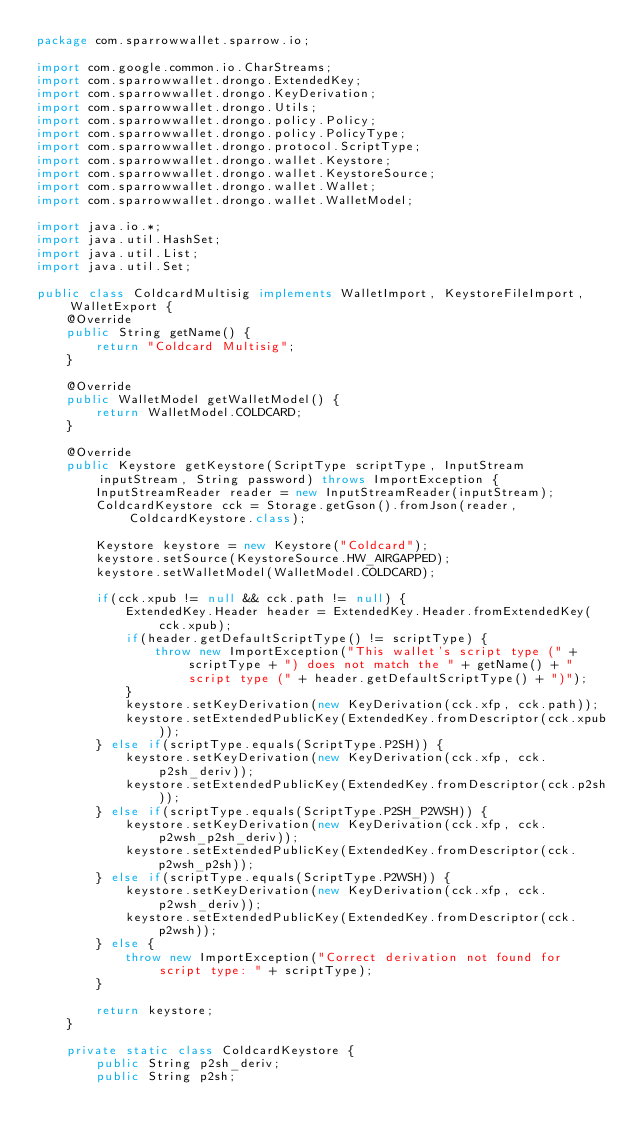<code> <loc_0><loc_0><loc_500><loc_500><_Java_>package com.sparrowwallet.sparrow.io;

import com.google.common.io.CharStreams;
import com.sparrowwallet.drongo.ExtendedKey;
import com.sparrowwallet.drongo.KeyDerivation;
import com.sparrowwallet.drongo.Utils;
import com.sparrowwallet.drongo.policy.Policy;
import com.sparrowwallet.drongo.policy.PolicyType;
import com.sparrowwallet.drongo.protocol.ScriptType;
import com.sparrowwallet.drongo.wallet.Keystore;
import com.sparrowwallet.drongo.wallet.KeystoreSource;
import com.sparrowwallet.drongo.wallet.Wallet;
import com.sparrowwallet.drongo.wallet.WalletModel;

import java.io.*;
import java.util.HashSet;
import java.util.List;
import java.util.Set;

public class ColdcardMultisig implements WalletImport, KeystoreFileImport, WalletExport {
    @Override
    public String getName() {
        return "Coldcard Multisig";
    }

    @Override
    public WalletModel getWalletModel() {
        return WalletModel.COLDCARD;
    }

    @Override
    public Keystore getKeystore(ScriptType scriptType, InputStream inputStream, String password) throws ImportException {
        InputStreamReader reader = new InputStreamReader(inputStream);
        ColdcardKeystore cck = Storage.getGson().fromJson(reader, ColdcardKeystore.class);

        Keystore keystore = new Keystore("Coldcard");
        keystore.setSource(KeystoreSource.HW_AIRGAPPED);
        keystore.setWalletModel(WalletModel.COLDCARD);

        if(cck.xpub != null && cck.path != null) {
            ExtendedKey.Header header = ExtendedKey.Header.fromExtendedKey(cck.xpub);
            if(header.getDefaultScriptType() != scriptType) {
                throw new ImportException("This wallet's script type (" + scriptType + ") does not match the " + getName() + " script type (" + header.getDefaultScriptType() + ")");
            }
            keystore.setKeyDerivation(new KeyDerivation(cck.xfp, cck.path));
            keystore.setExtendedPublicKey(ExtendedKey.fromDescriptor(cck.xpub));
        } else if(scriptType.equals(ScriptType.P2SH)) {
            keystore.setKeyDerivation(new KeyDerivation(cck.xfp, cck.p2sh_deriv));
            keystore.setExtendedPublicKey(ExtendedKey.fromDescriptor(cck.p2sh));
        } else if(scriptType.equals(ScriptType.P2SH_P2WSH)) {
            keystore.setKeyDerivation(new KeyDerivation(cck.xfp, cck.p2wsh_p2sh_deriv));
            keystore.setExtendedPublicKey(ExtendedKey.fromDescriptor(cck.p2wsh_p2sh));
        } else if(scriptType.equals(ScriptType.P2WSH)) {
            keystore.setKeyDerivation(new KeyDerivation(cck.xfp, cck.p2wsh_deriv));
            keystore.setExtendedPublicKey(ExtendedKey.fromDescriptor(cck.p2wsh));
        } else {
            throw new ImportException("Correct derivation not found for script type: " + scriptType);
        }

        return keystore;
    }

    private static class ColdcardKeystore {
        public String p2sh_deriv;
        public String p2sh;</code> 